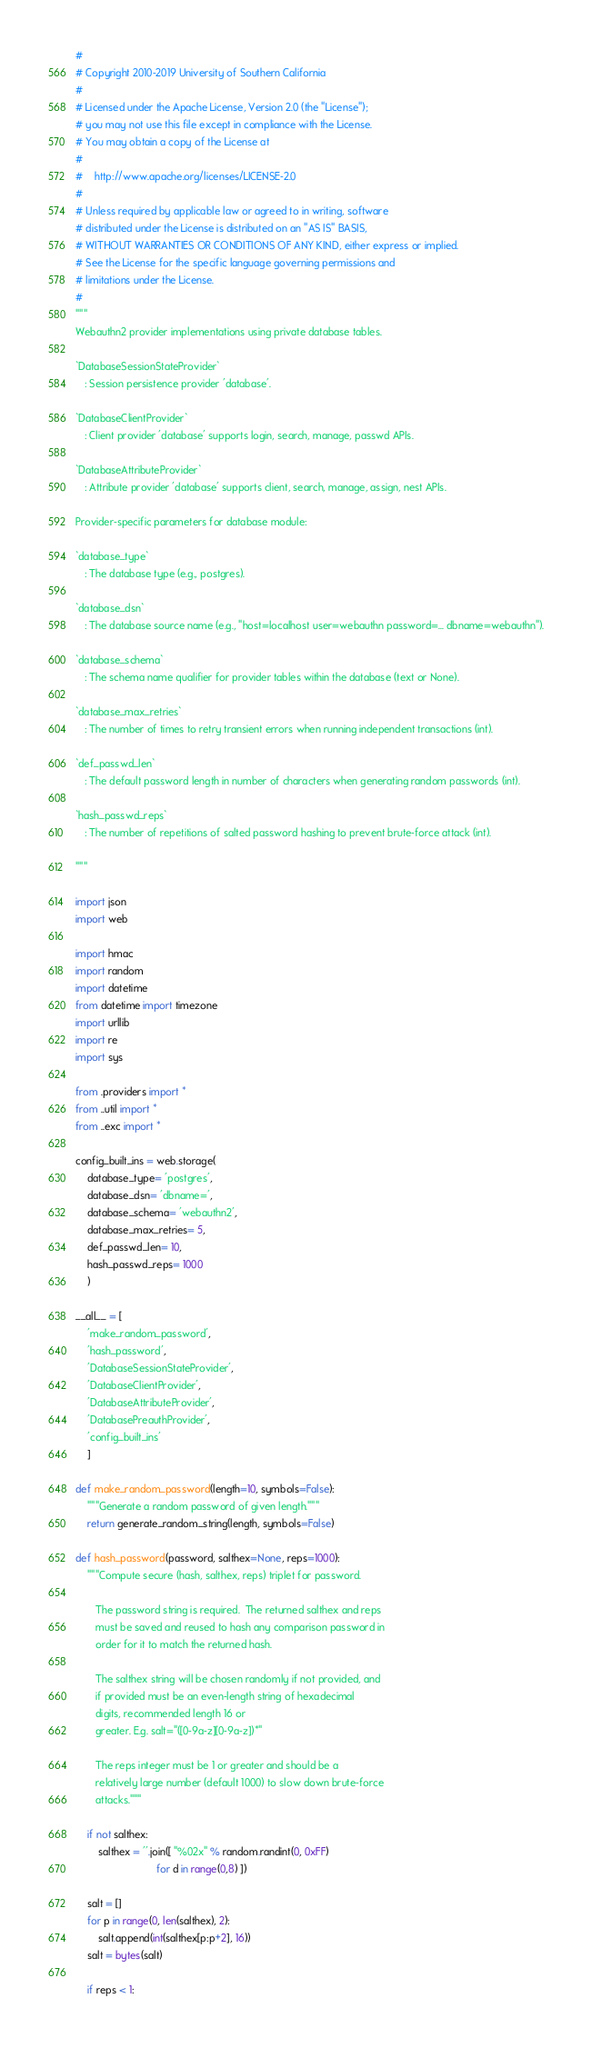Convert code to text. <code><loc_0><loc_0><loc_500><loc_500><_Python_>
# 
# Copyright 2010-2019 University of Southern California
# 
# Licensed under the Apache License, Version 2.0 (the "License");
# you may not use this file except in compliance with the License.
# You may obtain a copy of the License at
# 
#    http://www.apache.org/licenses/LICENSE-2.0
# 
# Unless required by applicable law or agreed to in writing, software
# distributed under the License is distributed on an "AS IS" BASIS,
# WITHOUT WARRANTIES OR CONDITIONS OF ANY KIND, either express or implied.
# See the License for the specific language governing permissions and
# limitations under the License.
#
"""
Webauthn2 provider implementations using private database tables.

`DatabaseSessionStateProvider`
   : Session persistence provider 'database'.

`DatabaseClientProvider`
   : Client provider 'database' supports login, search, manage, passwd APIs.

`DatabaseAttributeProvider`
   : Attribute provider 'database' supports client, search, manage, assign, nest APIs.

Provider-specific parameters for database module:

`database_type`
   : The database type (e.g., postgres).

`database_dsn`
   : The database source name (e.g., "host=localhost user=webauthn password=... dbname=webauthn").

`database_schema`
   : The schema name qualifier for provider tables within the database (text or None).

`database_max_retries`
   : The number of times to retry transient errors when running independent transactions (int).

`def_passwd_len`
   : The default password length in number of characters when generating random passwords (int).

`hash_passwd_reps`
   : The number of repetitions of salted password hashing to prevent brute-force attack (int).

"""

import json
import web

import hmac
import random
import datetime
from datetime import timezone
import urllib
import re
import sys

from .providers import *
from ..util import *
from ..exc import *

config_built_ins = web.storage(
    database_type= 'postgres',
    database_dsn= 'dbname=',
    database_schema= 'webauthn2',
    database_max_retries= 5,
    def_passwd_len= 10,
    hash_passwd_reps= 1000
    )

__all__ = [
    'make_random_password',
    'hash_password',
    'DatabaseSessionStateProvider',
    'DatabaseClientProvider',
    'DatabaseAttributeProvider',
    'DatabasePreauthProvider',
    'config_built_ins'
    ]

def make_random_password(length=10, symbols=False):
    """Generate a random password of given length."""
    return generate_random_string(length, symbols=False)

def hash_password(password, salthex=None, reps=1000):
    """Compute secure (hash, salthex, reps) triplet for password.

       The password string is required.  The returned salthex and reps
       must be saved and reused to hash any comparison password in
       order for it to match the returned hash.

       The salthex string will be chosen randomly if not provided, and
       if provided must be an even-length string of hexadecimal
       digits, recommended length 16 or
       greater. E.g. salt="([0-9a-z][0-9a-z])*"

       The reps integer must be 1 or greater and should be a
       relatively large number (default 1000) to slow down brute-force
       attacks."""
    
    if not salthex:
        salthex = ''.join([ "%02x" % random.randint(0, 0xFF) 
                            for d in range(0,8) ])

    salt = []
    for p in range(0, len(salthex), 2):
        salt.append(int(salthex[p:p+2], 16))
    salt = bytes(salt)

    if reps < 1:</code> 